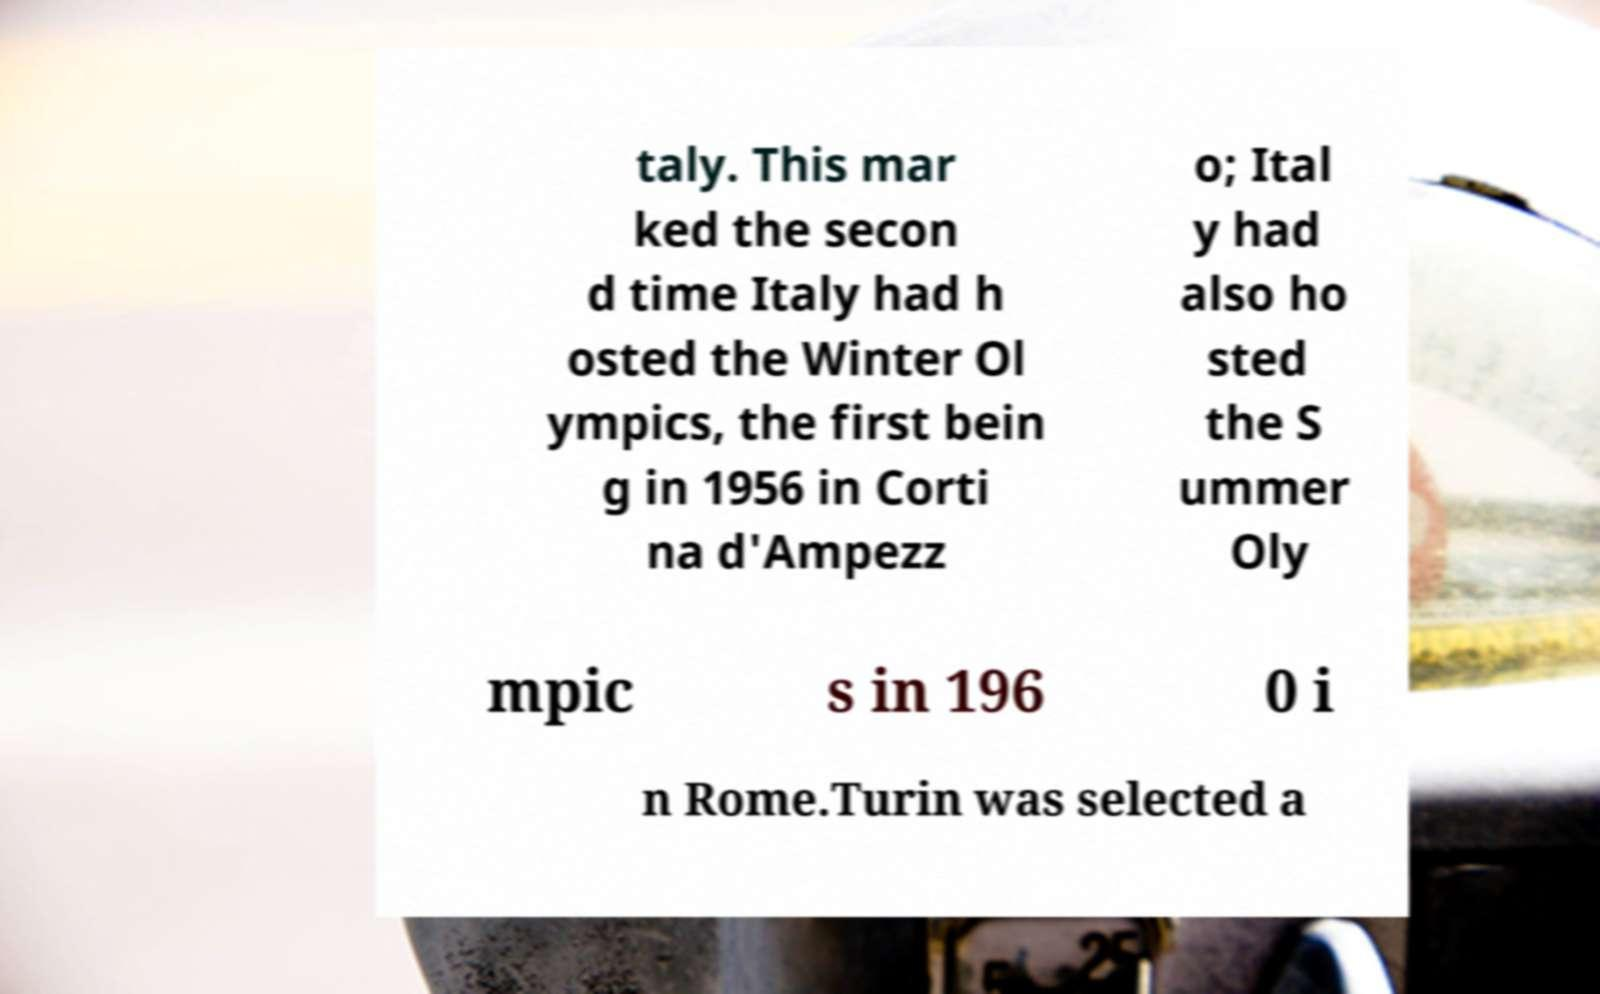There's text embedded in this image that I need extracted. Can you transcribe it verbatim? taly. This mar ked the secon d time Italy had h osted the Winter Ol ympics, the first bein g in 1956 in Corti na d'Ampezz o; Ital y had also ho sted the S ummer Oly mpic s in 196 0 i n Rome.Turin was selected a 